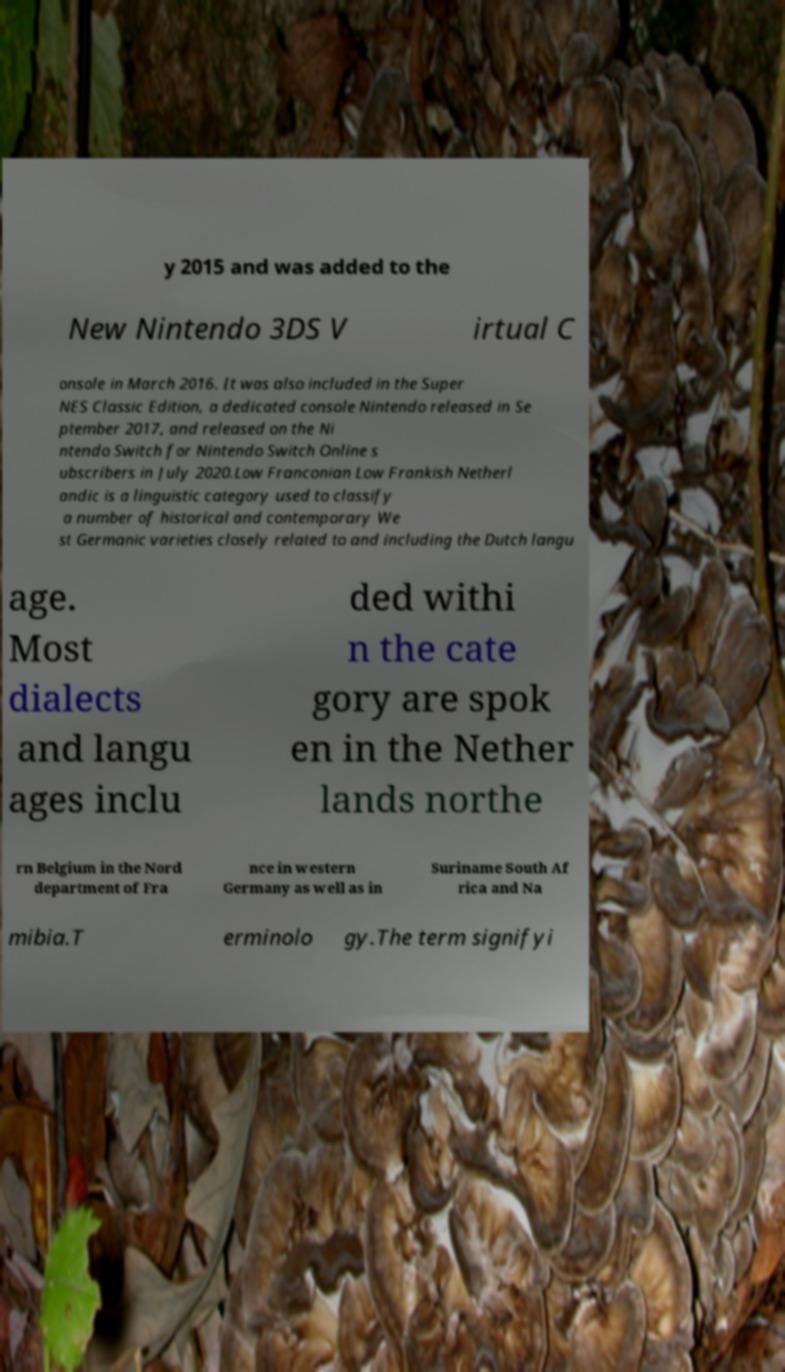What messages or text are displayed in this image? I need them in a readable, typed format. y 2015 and was added to the New Nintendo 3DS V irtual C onsole in March 2016. It was also included in the Super NES Classic Edition, a dedicated console Nintendo released in Se ptember 2017, and released on the Ni ntendo Switch for Nintendo Switch Online s ubscribers in July 2020.Low Franconian Low Frankish Netherl andic is a linguistic category used to classify a number of historical and contemporary We st Germanic varieties closely related to and including the Dutch langu age. Most dialects and langu ages inclu ded withi n the cate gory are spok en in the Nether lands northe rn Belgium in the Nord department of Fra nce in western Germany as well as in Suriname South Af rica and Na mibia.T erminolo gy.The term signifyi 